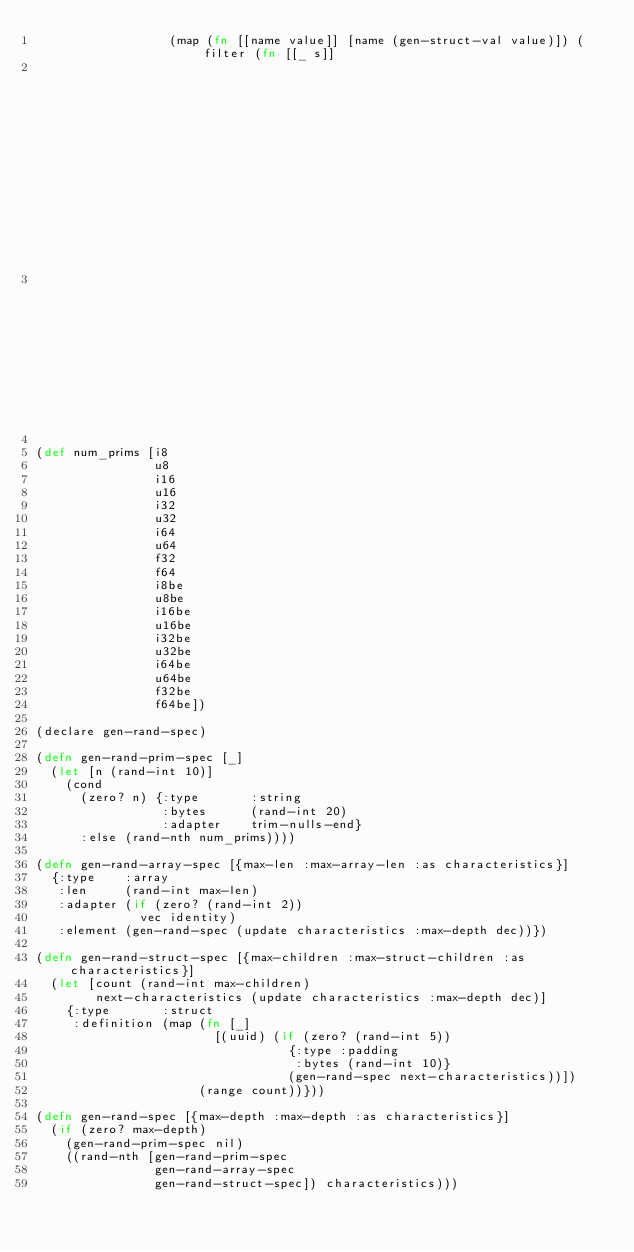Convert code to text. <code><loc_0><loc_0><loc_500><loc_500><_Clojure_>                  (map (fn [[name value]] [name (gen-struct-val value)]) (filter (fn [[_ s]]
                                                                                   (not= (s :type) :padding))
                                                                                 (spec :definition))))))

(def num_prims [i8
                u8
                i16
                u16
                i32
                u32
                i64
                u64
                f32
                f64
                i8be
                u8be
                i16be
                u16be
                i32be
                u32be
                i64be
                u64be
                f32be
                f64be])

(declare gen-rand-spec)

(defn gen-rand-prim-spec [_]
  (let [n (rand-int 10)]
    (cond
      (zero? n) {:type       :string
                 :bytes      (rand-int 20)
                 :adapter    trim-nulls-end}
      :else (rand-nth num_prims))))

(defn gen-rand-array-spec [{max-len :max-array-len :as characteristics}]
  {:type    :array
   :len     (rand-int max-len)
   :adapter (if (zero? (rand-int 2))
              vec identity)
   :element (gen-rand-spec (update characteristics :max-depth dec))})

(defn gen-rand-struct-spec [{max-children :max-struct-children :as characteristics}]
  (let [count (rand-int max-children)
        next-characteristics (update characteristics :max-depth dec)]
    {:type       :struct
     :definition (map (fn [_]
                        [(uuid) (if (zero? (rand-int 5))
                                  {:type :padding
                                   :bytes (rand-int 10)}
                                  (gen-rand-spec next-characteristics))])
                      (range count))}))

(defn gen-rand-spec [{max-depth :max-depth :as characteristics}]
  (if (zero? max-depth)
    (gen-rand-prim-spec nil)
    ((rand-nth [gen-rand-prim-spec
                gen-rand-array-spec
                gen-rand-struct-spec]) characteristics)))

</code> 